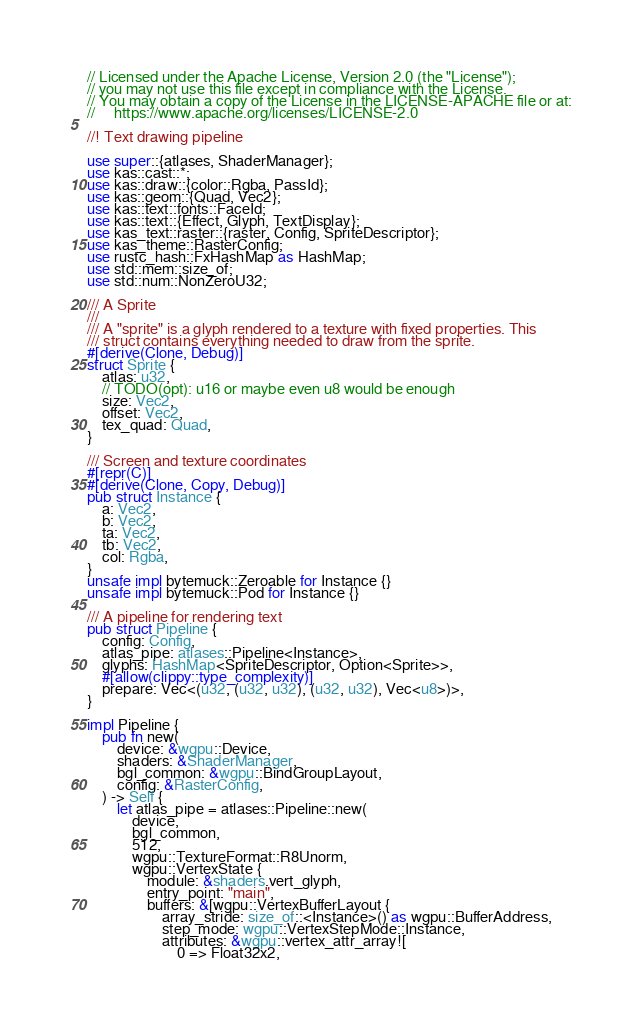Convert code to text. <code><loc_0><loc_0><loc_500><loc_500><_Rust_>// Licensed under the Apache License, Version 2.0 (the "License");
// you may not use this file except in compliance with the License.
// You may obtain a copy of the License in the LICENSE-APACHE file or at:
//     https://www.apache.org/licenses/LICENSE-2.0

//! Text drawing pipeline

use super::{atlases, ShaderManager};
use kas::cast::*;
use kas::draw::{color::Rgba, PassId};
use kas::geom::{Quad, Vec2};
use kas::text::fonts::FaceId;
use kas::text::{Effect, Glyph, TextDisplay};
use kas_text::raster::{raster, Config, SpriteDescriptor};
use kas_theme::RasterConfig;
use rustc_hash::FxHashMap as HashMap;
use std::mem::size_of;
use std::num::NonZeroU32;

/// A Sprite
///
/// A "sprite" is a glyph rendered to a texture with fixed properties. This
/// struct contains everything needed to draw from the sprite.
#[derive(Clone, Debug)]
struct Sprite {
    atlas: u32,
    // TODO(opt): u16 or maybe even u8 would be enough
    size: Vec2,
    offset: Vec2,
    tex_quad: Quad,
}

/// Screen and texture coordinates
#[repr(C)]
#[derive(Clone, Copy, Debug)]
pub struct Instance {
    a: Vec2,
    b: Vec2,
    ta: Vec2,
    tb: Vec2,
    col: Rgba,
}
unsafe impl bytemuck::Zeroable for Instance {}
unsafe impl bytemuck::Pod for Instance {}

/// A pipeline for rendering text
pub struct Pipeline {
    config: Config,
    atlas_pipe: atlases::Pipeline<Instance>,
    glyphs: HashMap<SpriteDescriptor, Option<Sprite>>,
    #[allow(clippy::type_complexity)]
    prepare: Vec<(u32, (u32, u32), (u32, u32), Vec<u8>)>,
}

impl Pipeline {
    pub fn new(
        device: &wgpu::Device,
        shaders: &ShaderManager,
        bgl_common: &wgpu::BindGroupLayout,
        config: &RasterConfig,
    ) -> Self {
        let atlas_pipe = atlases::Pipeline::new(
            device,
            bgl_common,
            512,
            wgpu::TextureFormat::R8Unorm,
            wgpu::VertexState {
                module: &shaders.vert_glyph,
                entry_point: "main",
                buffers: &[wgpu::VertexBufferLayout {
                    array_stride: size_of::<Instance>() as wgpu::BufferAddress,
                    step_mode: wgpu::VertexStepMode::Instance,
                    attributes: &wgpu::vertex_attr_array![
                        0 => Float32x2,</code> 